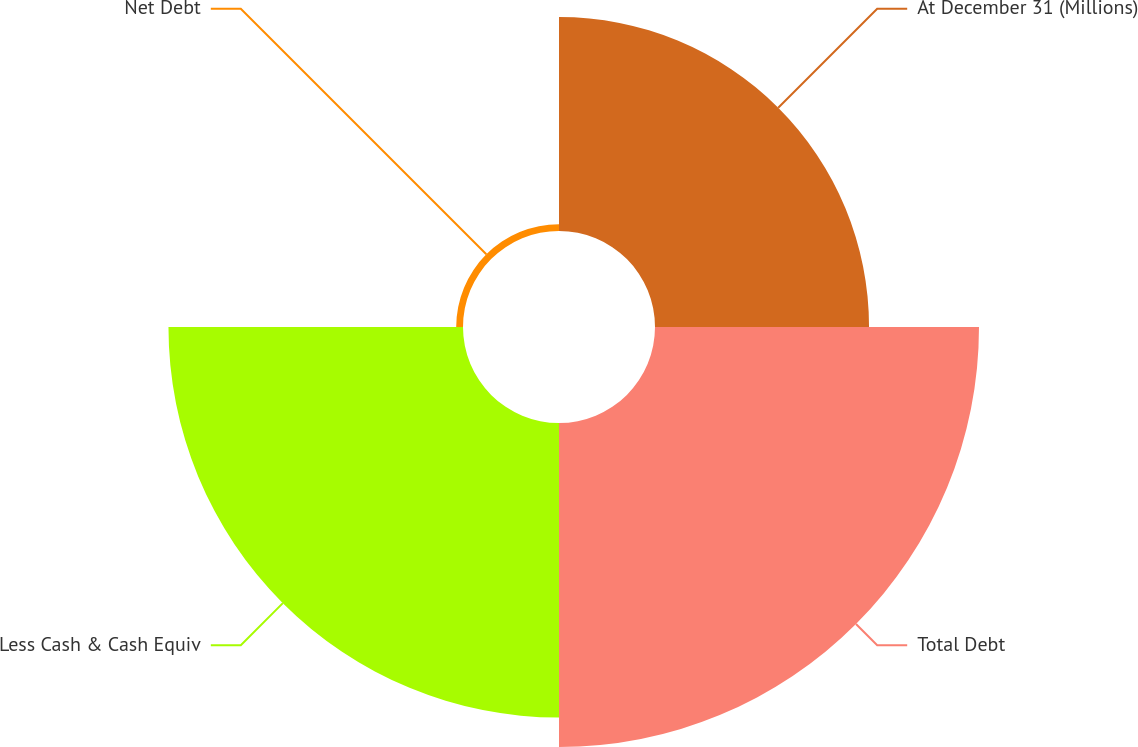<chart> <loc_0><loc_0><loc_500><loc_500><pie_chart><fcel>At December 31 (Millions)<fcel>Total Debt<fcel>Less Cash & Cash Equiv<fcel>Net Debt<nl><fcel>25.5%<fcel>38.6%<fcel>35.09%<fcel>0.81%<nl></chart> 